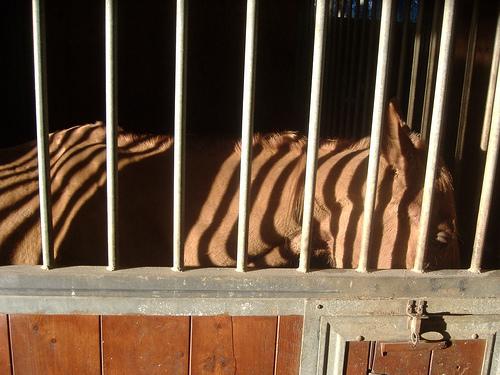Is this a zebra?
Answer briefly. No. Is it sunny?
Quick response, please. Yes. Are the animals in cages?
Answer briefly. Yes. 